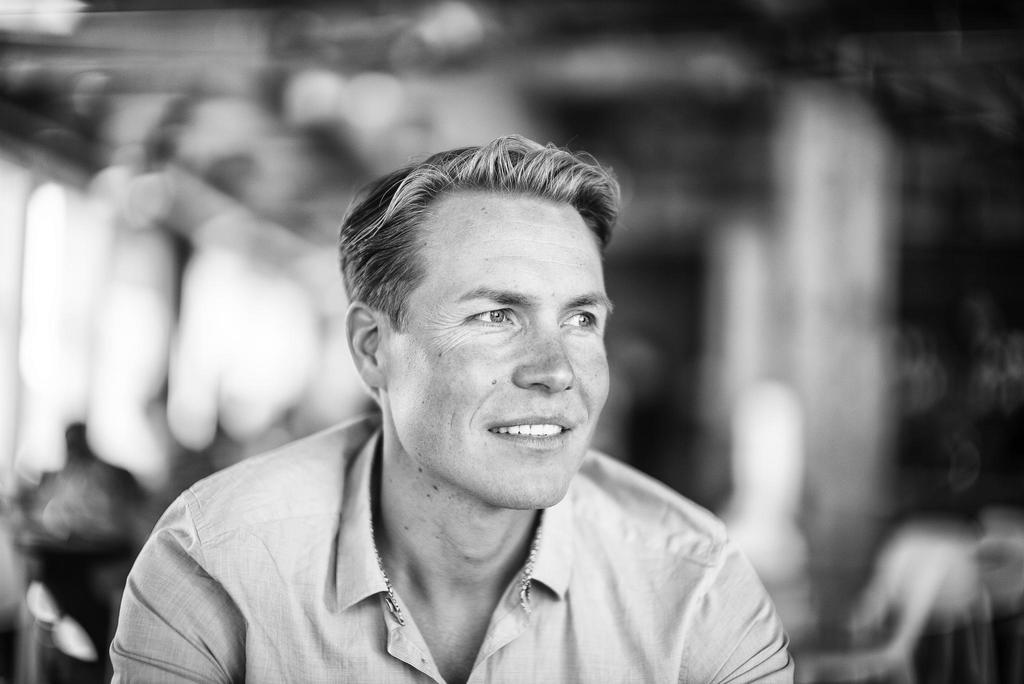What is the main subject of the image? The main subject of the image is a man. What is the man doing in the image? The man is sitting in the image. What expression does the man have on his face? The man is smiling in the image. Can you describe the background of the image? The background of the image is blurred. What type of camera is the man holding in the image? There is no camera visible in the image; the man is simply sitting and smiling. 